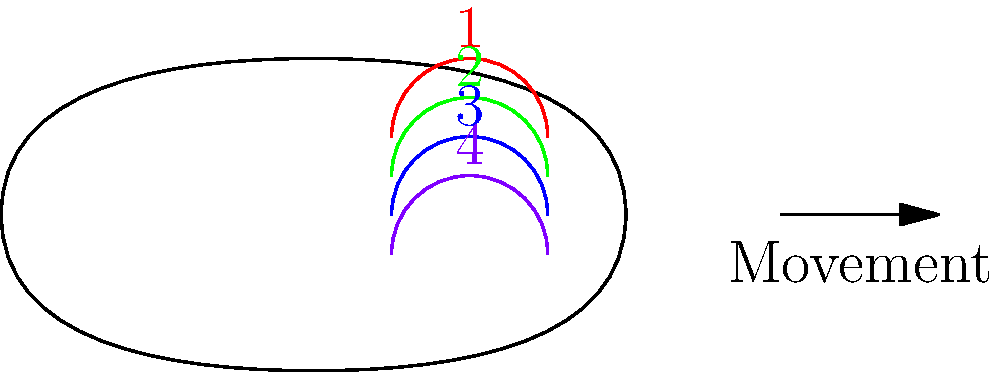In the diagram above, which sequence of fin positions (1-4) correctly represents the movement of a fish's pectoral fin during the power stroke of locomotion? To understand the correct sequence of fin positions during a fish's pectoral fin power stroke, let's break down the biomechanics:

1. Initial position: The fin starts in an anterior (forward) and dorsal (upward) position, represented by fin position 1 (red).

2. Downstroke begins: The fin moves posteriorly (backward) and ventrally (downward), transitioning to position 2 (green).

3. Mid-power stroke: The fin continues its posterior and ventral movement, reaching position 3 (blue).

4. End of power stroke: The fin completes its movement, reaching the most posterior and ventral position, represented by position 4 (purple).

This sequence (1-2-3-4) maximizes the fin's surface area during the power stroke, pushing water backwards and propelling the fish forward. The recovery stroke (not shown) would involve the fin moving back to the initial position with reduced resistance.

The biomechanics of this movement are based on the principle of action and reaction forces in fluid dynamics. As the fin pushes water backwards, the fish experiences an equal and opposite force propelling it forward, in accordance with Newton's Third Law of Motion.
Answer: 1-2-3-4 